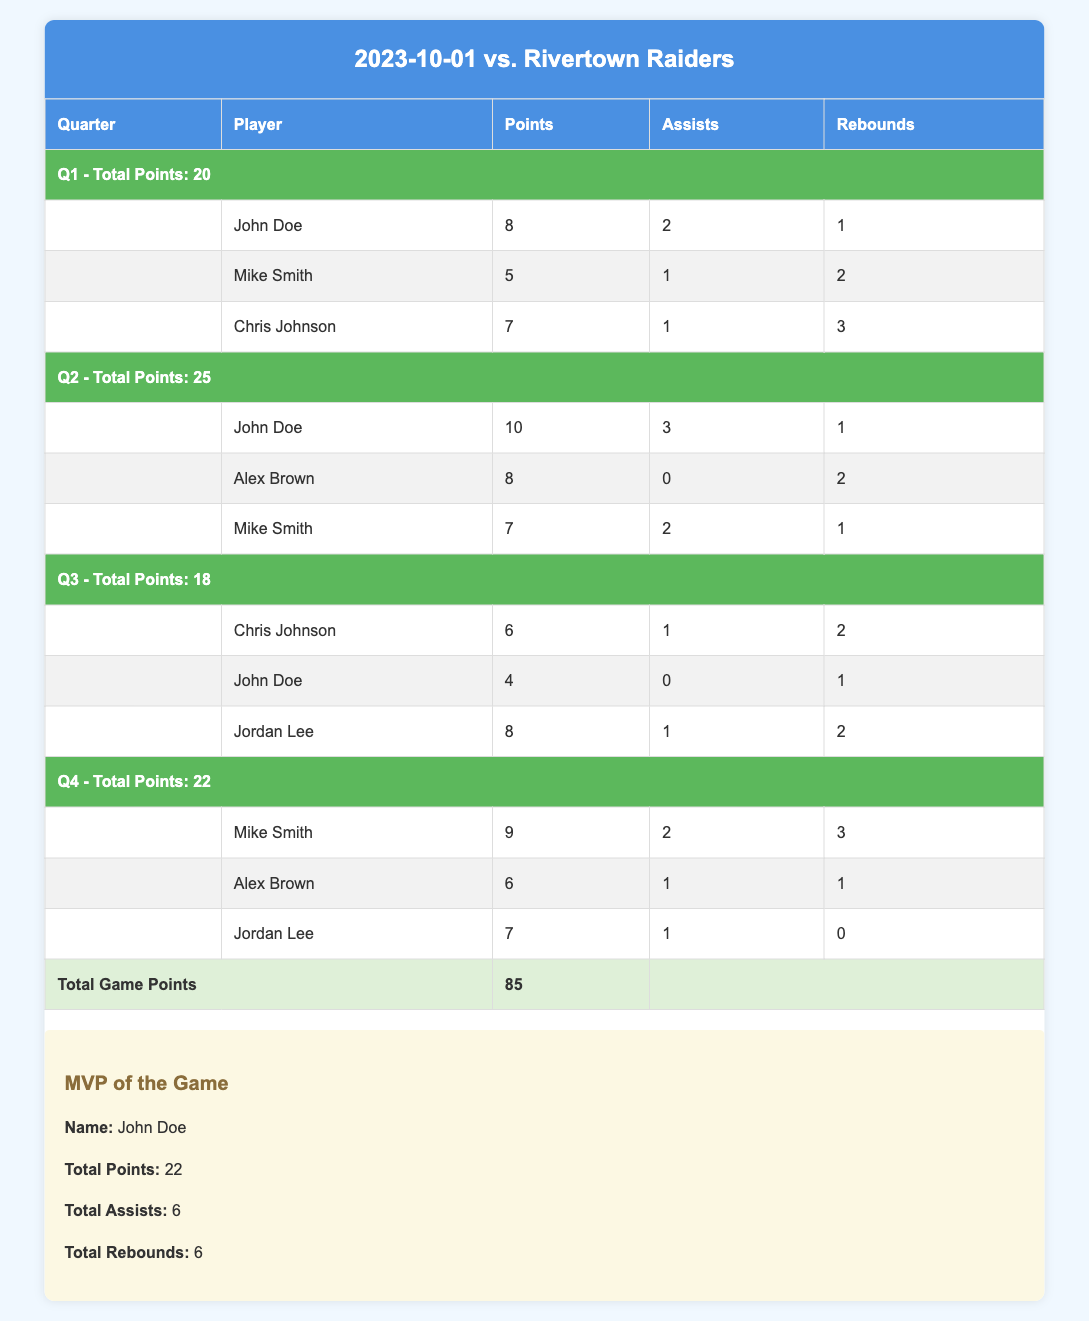What is the total points scored by John Doe in the game? Summing up John Doe’s points scored in each quarter: Q1: 8, Q2: 10, Q3: 4, Q4: 0. So, 8 + 10 + 4 + 0 = 22.
Answer: 22 How many assists did Chris Johnson make in total? Adding assists made by Chris Johnson in each quarter: Q1: 2, Q3: 1. Therefore, 2 + 1 = 3.
Answer: 3 Which quarter had the highest total points scored? Evaluating the total points for each quarter: Q1: 20, Q2: 25, Q3: 18, Q4: 22. The highest is Q2 with 25 points.
Answer: Q2 Did Mike Smith score in every quarter? Checking Mike Smith’s points: Q1: 5, Q2: 7, Q3: 0, Q4: 9. He did not score in Q3.
Answer: No What is the average number of rebounds for Alex Brown across the quarters he played? Alex Brown's rebounds: Q2: 2, Q4: 1. Total rebounds = 2 + 1 = 3. He played in 2 quarters, so average = 3/2 = 1.5.
Answer: 1.5 Which player contributed the most assists in Q2? In Q2, players' assists were: John Doe: 3, Alex Brown: 0, Mike Smith: 2. John Doe has the highest assists with 3.
Answer: John Doe If we combine the points scored by Jordan Lee in Q3 and Q4, what would be the total? For Jordan Lee: Q3: 8, Q4: 7. Adding these gives 8 + 7 = 15.
Answer: 15 What was the total number of rebounds by the MVP, John Doe? John Doe’s rebounds are: Q1: 1, Q2: 1, Q3: 1, Q4: 0. Adding these yields 1 + 1 + 1 + 0 = 3.
Answer: 3 Did any player score more than 10 points in a single quarter? Checking player's maximum points for each quarter: John Doe (Q2: 10), Mike Smith (Q4: 9), Chris Johnson (Q1: 7) etc. No player exceeded 10 points in any quarter.
Answer: No 